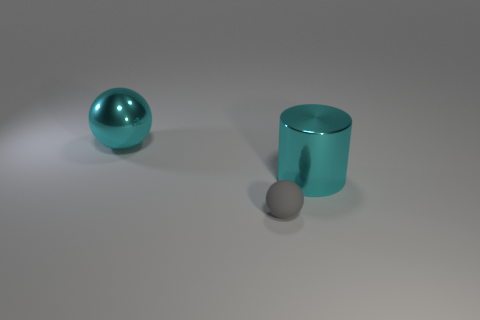There is a object that is the same size as the shiny sphere; what is its material?
Provide a short and direct response. Metal. Does the cyan thing that is behind the large shiny cylinder have the same size as the metal cylinder in front of the metal sphere?
Offer a very short reply. Yes. Is there a big yellow sphere made of the same material as the small ball?
Your answer should be very brief. No. How many things are big cyan shiny things on the left side of the small gray sphere or small brown shiny cubes?
Keep it short and to the point. 1. Does the object that is behind the cylinder have the same material as the big cyan cylinder?
Offer a terse response. Yes. There is a big thing in front of the cyan metallic ball; what number of large cyan cylinders are in front of it?
Your answer should be compact. 0. What is the material of the other thing that is the same shape as the gray matte object?
Provide a short and direct response. Metal. There is a large object that is on the right side of the metal ball; does it have the same color as the big shiny ball?
Offer a terse response. Yes. Does the big cylinder have the same material as the big cyan thing on the left side of the gray matte thing?
Provide a succinct answer. Yes. There is a large cyan shiny object left of the tiny gray rubber thing; what shape is it?
Provide a short and direct response. Sphere. 